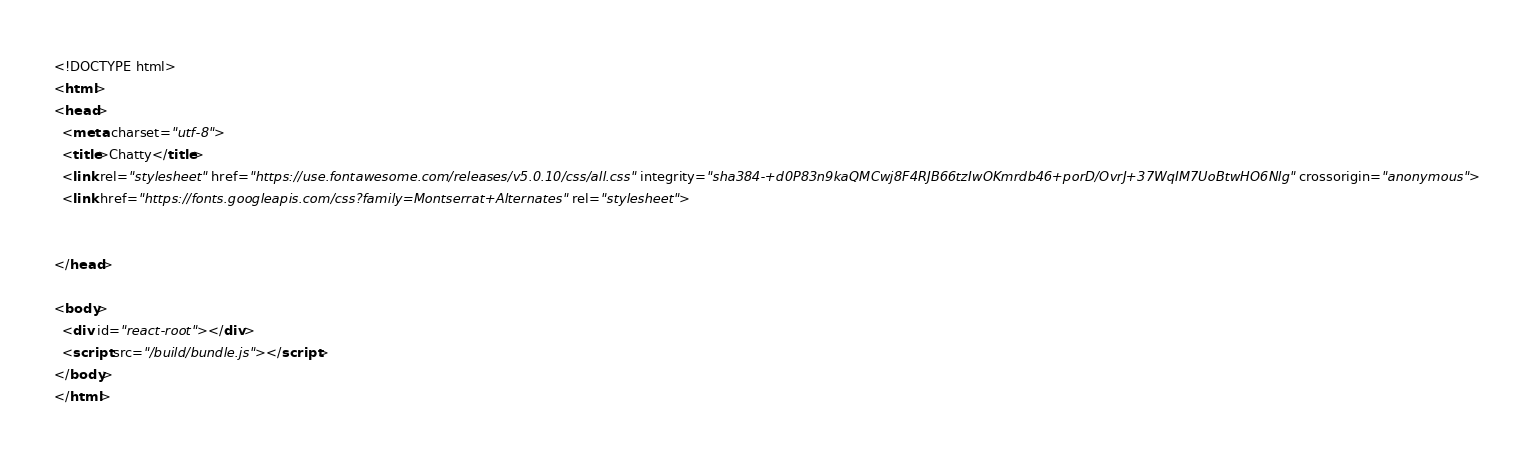Convert code to text. <code><loc_0><loc_0><loc_500><loc_500><_HTML_><!DOCTYPE html>
<html>
<head>
  <meta charset="utf-8">
  <title>Chatty</title>
  <link rel="stylesheet" href="https://use.fontawesome.com/releases/v5.0.10/css/all.css" integrity="sha384-+d0P83n9kaQMCwj8F4RJB66tzIwOKmrdb46+porD/OvrJ+37WqIM7UoBtwHO6Nlg" crossorigin="anonymous">
  <link href="https://fonts.googleapis.com/css?family=Montserrat+Alternates" rel="stylesheet">


</head>

<body>
  <div id="react-root"></div>
  <script src="/build/bundle.js"></script>
</body>
</html></code> 